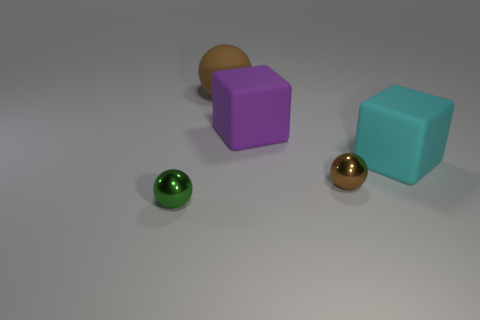There is a cyan object that is behind the metallic ball to the right of the brown matte thing; what shape is it?
Keep it short and to the point. Cube. There is another thing that is the same shape as the large purple rubber object; what color is it?
Your answer should be compact. Cyan. There is a brown sphere in front of the purple thing; is it the same size as the small green metallic ball?
Provide a short and direct response. Yes. How many balls are the same material as the green thing?
Your response must be concise. 1. What material is the thing that is in front of the small ball that is right of the small shiny thing on the left side of the large purple matte block made of?
Offer a terse response. Metal. The large thing right of the big matte cube that is to the left of the cyan matte thing is what color?
Your answer should be compact. Cyan. What is the color of the block that is the same size as the purple object?
Keep it short and to the point. Cyan. What number of big objects are either cyan objects or purple things?
Offer a very short reply. 2. Is the number of cyan matte cubes in front of the large brown rubber object greater than the number of big cyan matte objects that are left of the big cyan rubber object?
Provide a succinct answer. Yes. What is the size of the metallic object that is the same color as the large rubber sphere?
Make the answer very short. Small. 